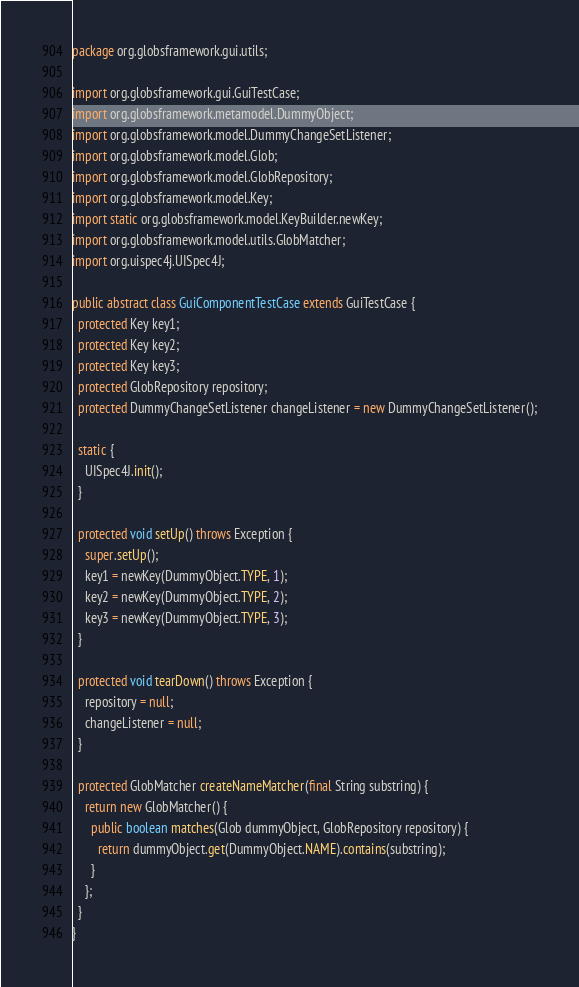Convert code to text. <code><loc_0><loc_0><loc_500><loc_500><_Java_>package org.globsframework.gui.utils;

import org.globsframework.gui.GuiTestCase;
import org.globsframework.metamodel.DummyObject;
import org.globsframework.model.DummyChangeSetListener;
import org.globsframework.model.Glob;
import org.globsframework.model.GlobRepository;
import org.globsframework.model.Key;
import static org.globsframework.model.KeyBuilder.newKey;
import org.globsframework.model.utils.GlobMatcher;
import org.uispec4j.UISpec4J;

public abstract class GuiComponentTestCase extends GuiTestCase {
  protected Key key1;
  protected Key key2;
  protected Key key3;
  protected GlobRepository repository;
  protected DummyChangeSetListener changeListener = new DummyChangeSetListener();

  static {
    UISpec4J.init();
  }

  protected void setUp() throws Exception {
    super.setUp();
    key1 = newKey(DummyObject.TYPE, 1);
    key2 = newKey(DummyObject.TYPE, 2);
    key3 = newKey(DummyObject.TYPE, 3);
  }

  protected void tearDown() throws Exception {
    repository = null;
    changeListener = null;
  }

  protected GlobMatcher createNameMatcher(final String substring) {
    return new GlobMatcher() {
      public boolean matches(Glob dummyObject, GlobRepository repository) {
        return dummyObject.get(DummyObject.NAME).contains(substring);
      }
    };
  }
}
</code> 